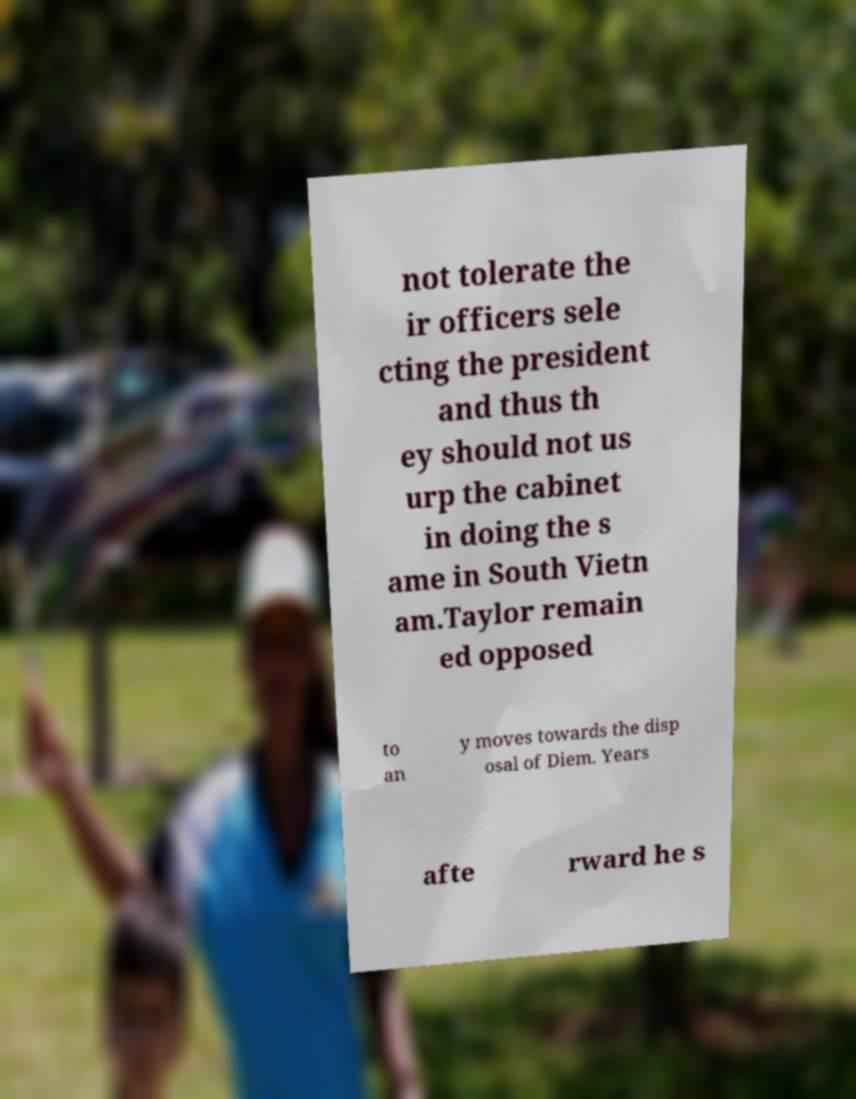Could you extract and type out the text from this image? not tolerate the ir officers sele cting the president and thus th ey should not us urp the cabinet in doing the s ame in South Vietn am.Taylor remain ed opposed to an y moves towards the disp osal of Diem. Years afte rward he s 